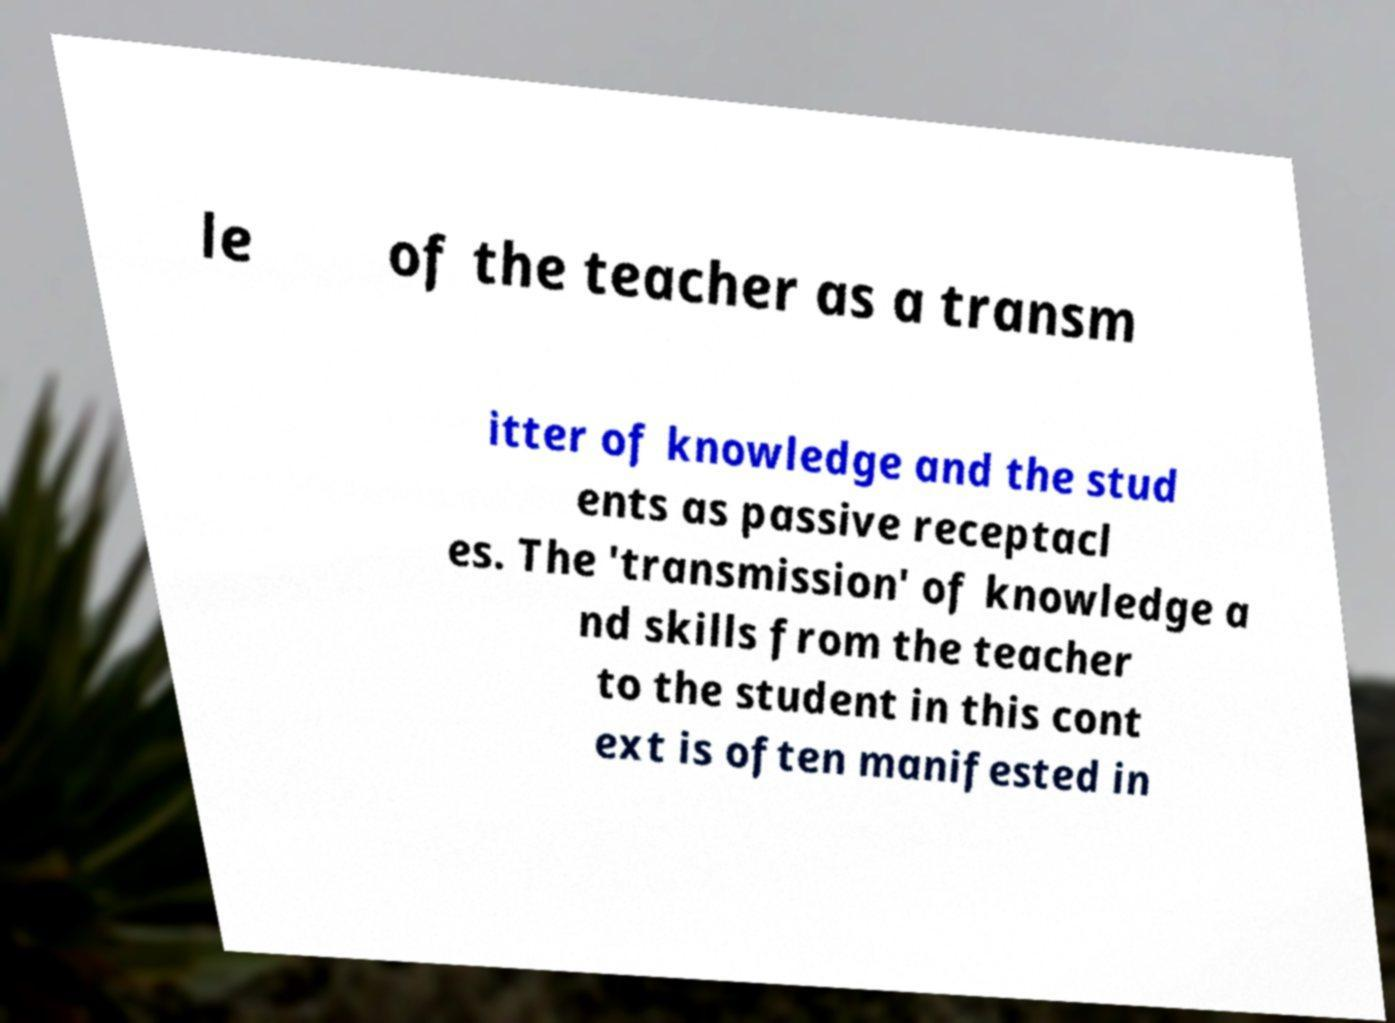There's text embedded in this image that I need extracted. Can you transcribe it verbatim? le of the teacher as a transm itter of knowledge and the stud ents as passive receptacl es. The 'transmission' of knowledge a nd skills from the teacher to the student in this cont ext is often manifested in 